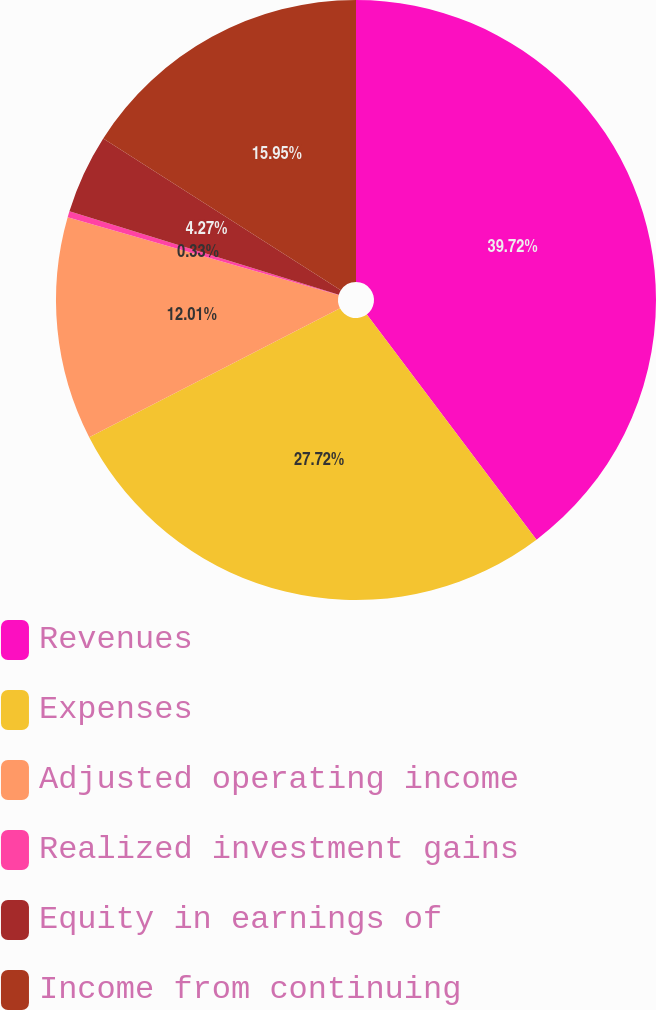Convert chart to OTSL. <chart><loc_0><loc_0><loc_500><loc_500><pie_chart><fcel>Revenues<fcel>Expenses<fcel>Adjusted operating income<fcel>Realized investment gains<fcel>Equity in earnings of<fcel>Income from continuing<nl><fcel>39.73%<fcel>27.72%<fcel>12.01%<fcel>0.33%<fcel>4.27%<fcel>15.95%<nl></chart> 